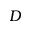<formula> <loc_0><loc_0><loc_500><loc_500>D</formula> 